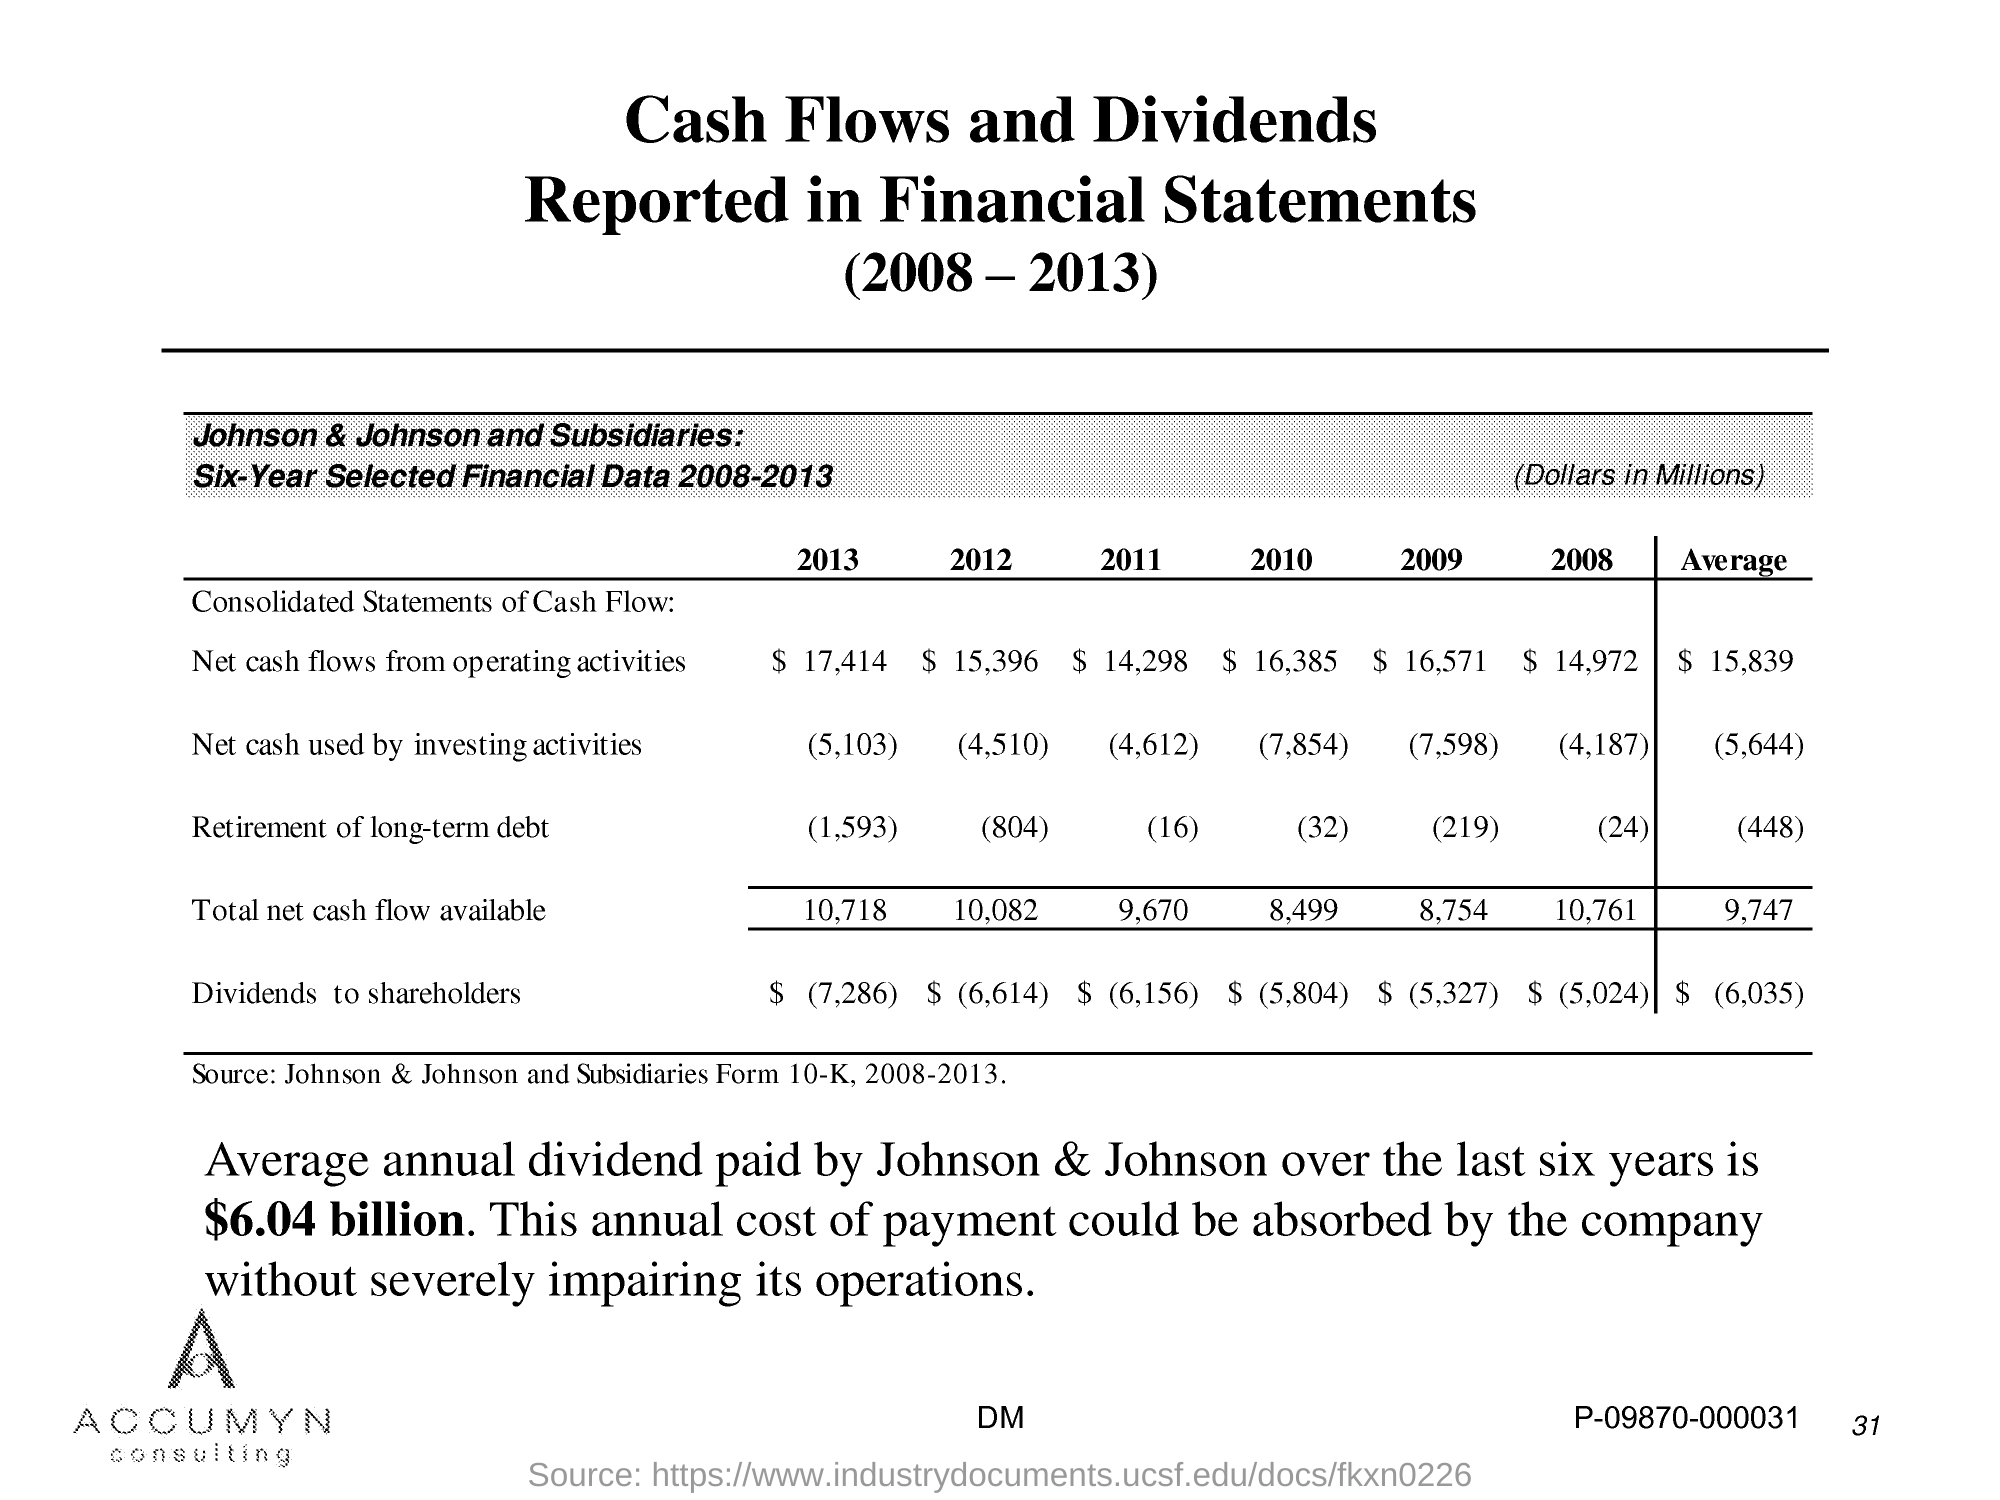Mention a couple of crucial points in this snapshot. The data in the table is sourced from Johnson & Johnson and its subsidiaries' Form 10-K annual reports for the years 2008 to 2013. Over the past six years, the average annual dividend paid by Johnson & Johnson has been approximately $6.04 billion. 